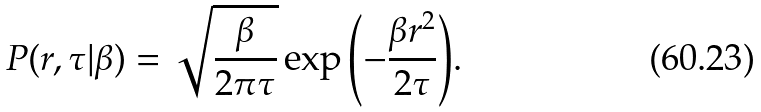Convert formula to latex. <formula><loc_0><loc_0><loc_500><loc_500>P ( r , \tau | \beta ) = \sqrt { \frac { \beta } { 2 \pi \tau } } \exp { \left ( - \frac { \beta r ^ { 2 } } { 2 \tau } \right ) } .</formula> 